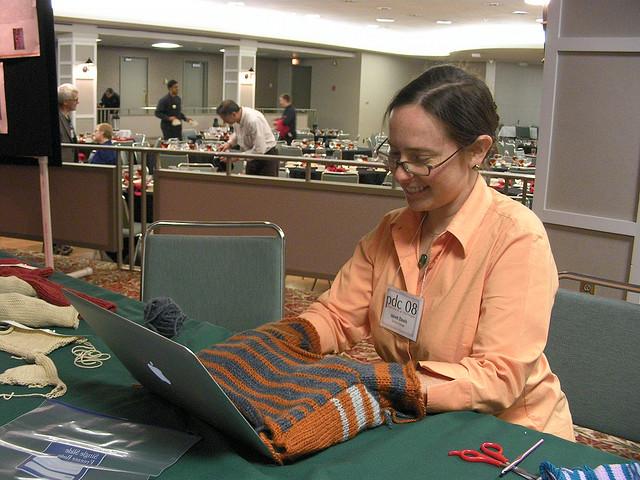Is the woman wearing glasses?
Concise answer only. Yes. What does this woman have on her hands?
Short answer required. Gloves. Is anyone in this workplace wearing a coat?
Give a very brief answer. No. 